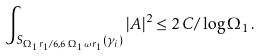<formula> <loc_0><loc_0><loc_500><loc_500>\int _ { S _ { \Omega _ { 1 } \, r _ { 1 } / 6 , 6 \, \Omega _ { 1 } \, \omega \, r _ { 1 } } ( \gamma _ { i } ) } | A | ^ { 2 } \leq 2 \, C / \log \Omega _ { 1 } \, .</formula> 